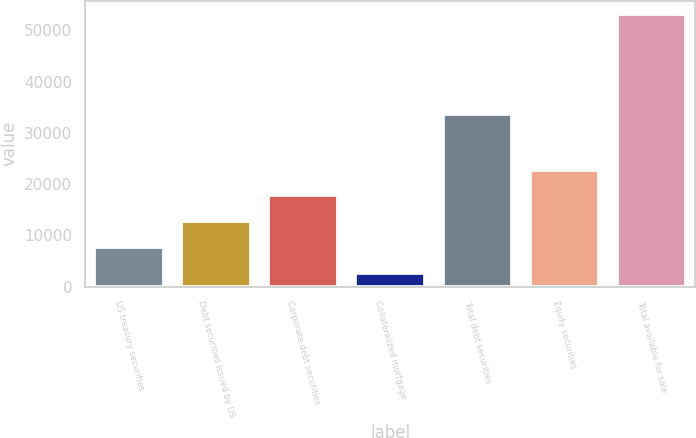Convert chart. <chart><loc_0><loc_0><loc_500><loc_500><bar_chart><fcel>US treasury securities<fcel>Debt securities issued by US<fcel>Corporate debt securities<fcel>Collateralized mortgage<fcel>Total debt securities<fcel>Equity securities<fcel>Total available for sale<nl><fcel>7713.1<fcel>12755.2<fcel>17797.3<fcel>2671<fcel>33687<fcel>22839.4<fcel>53092<nl></chart> 